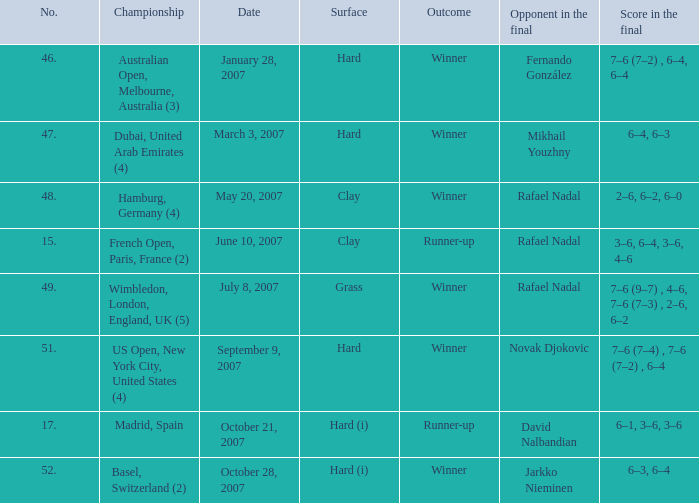Where the outcome is Winner and surface is Hard (i), what is the No.? 52.0. 